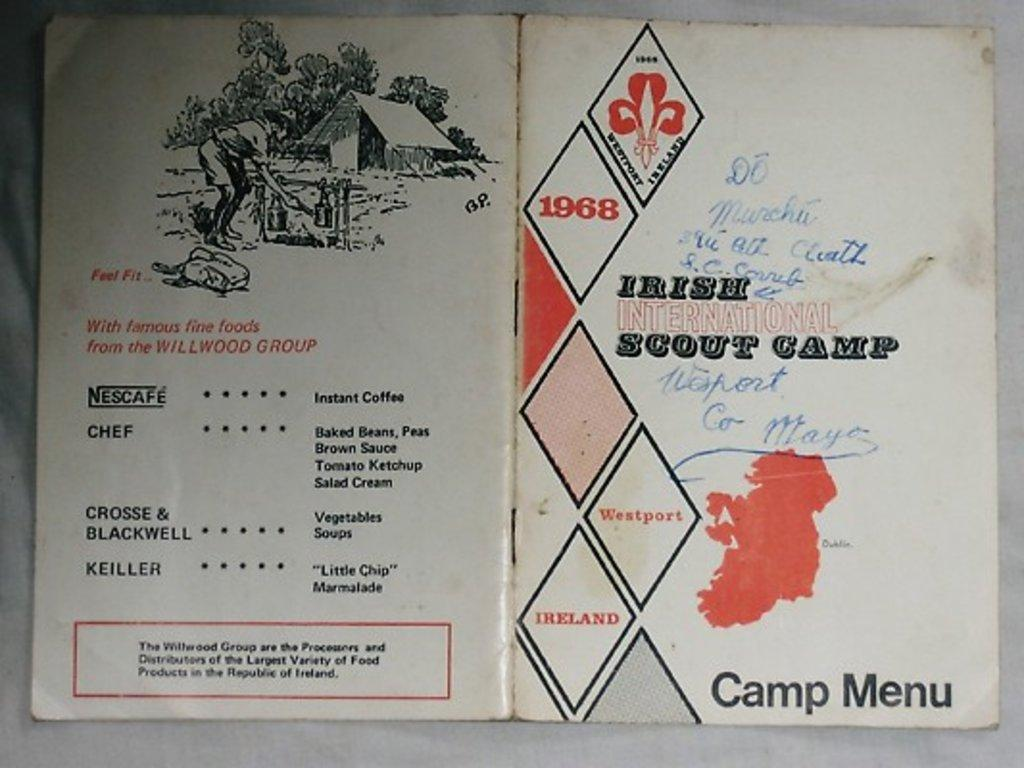<image>
Describe the image concisely. A menu for the Irish International Scout Camp for 1968. 